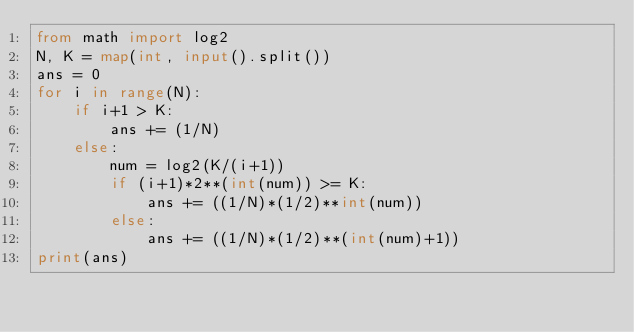<code> <loc_0><loc_0><loc_500><loc_500><_Python_>from math import log2
N, K = map(int, input().split())
ans = 0
for i in range(N):
    if i+1 > K:
        ans += (1/N)
    else:
        num = log2(K/(i+1))
        if (i+1)*2**(int(num)) >= K:
            ans += ((1/N)*(1/2)**int(num))
        else:
            ans += ((1/N)*(1/2)**(int(num)+1))
print(ans)
</code> 